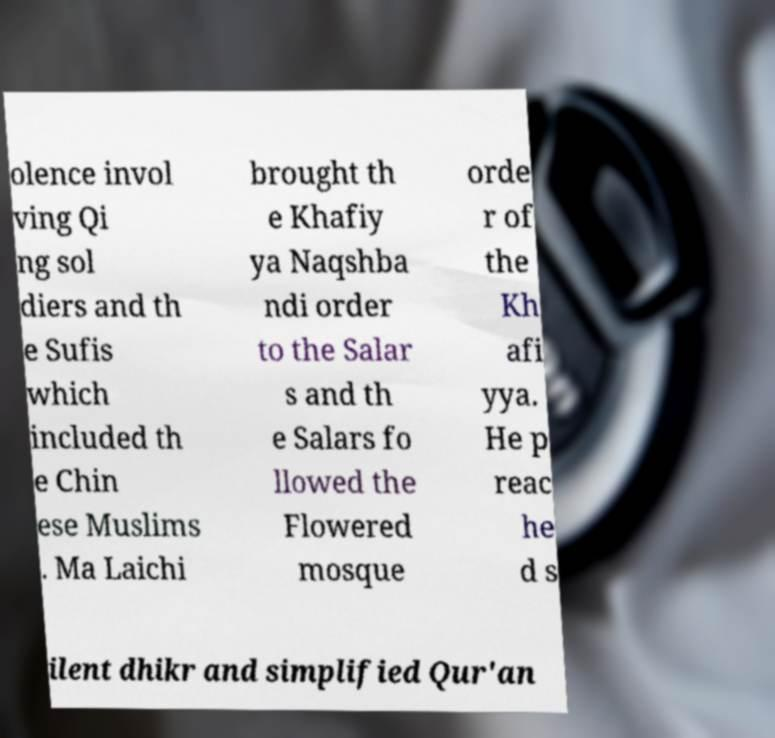Please identify and transcribe the text found in this image. olence invol ving Qi ng sol diers and th e Sufis which included th e Chin ese Muslims . Ma Laichi brought th e Khafiy ya Naqshba ndi order to the Salar s and th e Salars fo llowed the Flowered mosque orde r of the Kh afi yya. He p reac he d s ilent dhikr and simplified Qur'an 